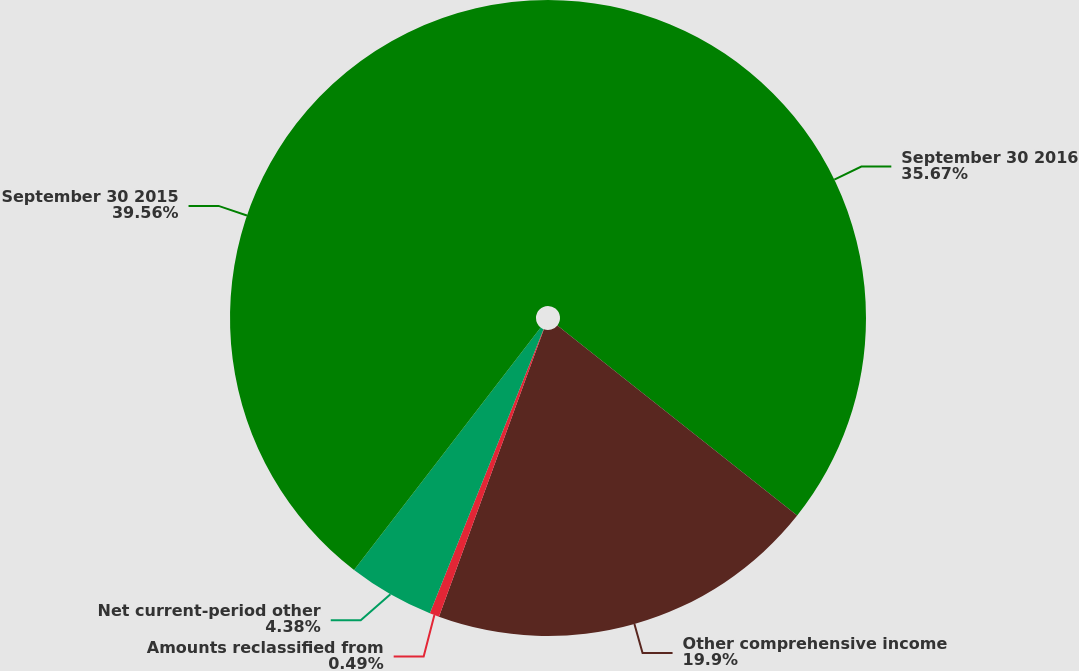<chart> <loc_0><loc_0><loc_500><loc_500><pie_chart><fcel>September 30 2016<fcel>Other comprehensive income<fcel>Amounts reclassified from<fcel>Net current-period other<fcel>September 30 2015<nl><fcel>35.67%<fcel>19.9%<fcel>0.49%<fcel>4.38%<fcel>39.56%<nl></chart> 